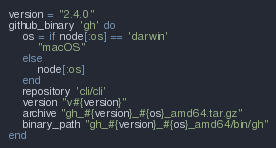<code> <loc_0><loc_0><loc_500><loc_500><_Ruby_>version = "2.4.0"
github_binary 'gh' do
    os = if node[:os] == 'darwin'
        "macOS"
    else
        node[:os]
    end
    repository 'cli/cli'
    version "v#{version}"
    archive "gh_#{version}_#{os}_amd64.tar.gz"
    binary_path "gh_#{version}_#{os}_amd64/bin/gh"
end
</code> 